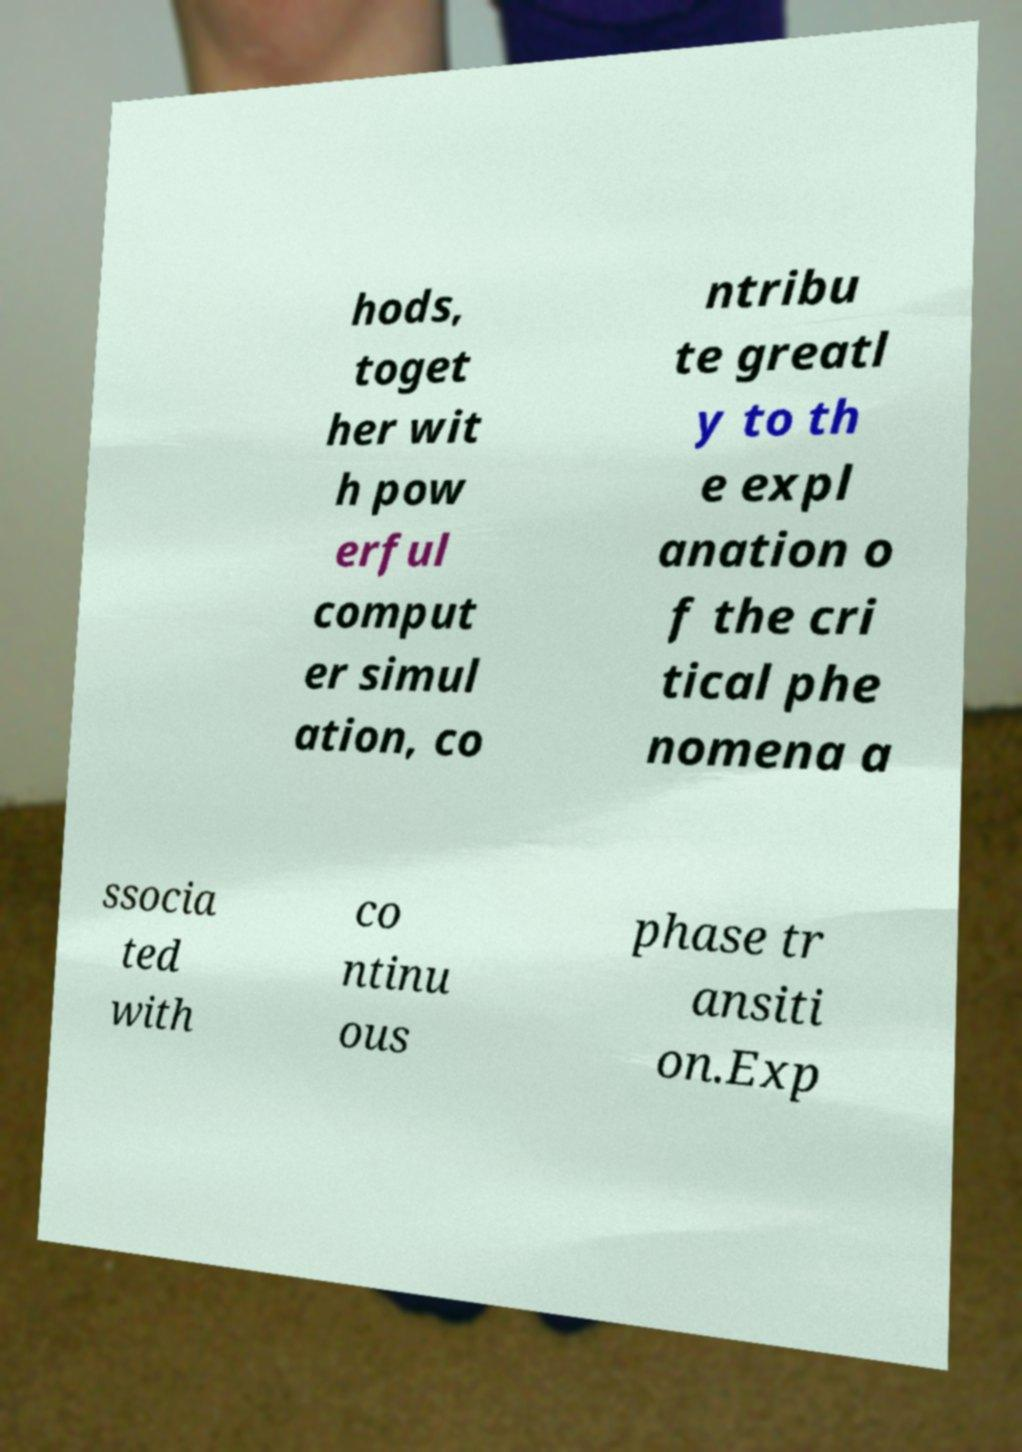Please read and relay the text visible in this image. What does it say? hods, toget her wit h pow erful comput er simul ation, co ntribu te greatl y to th e expl anation o f the cri tical phe nomena a ssocia ted with co ntinu ous phase tr ansiti on.Exp 